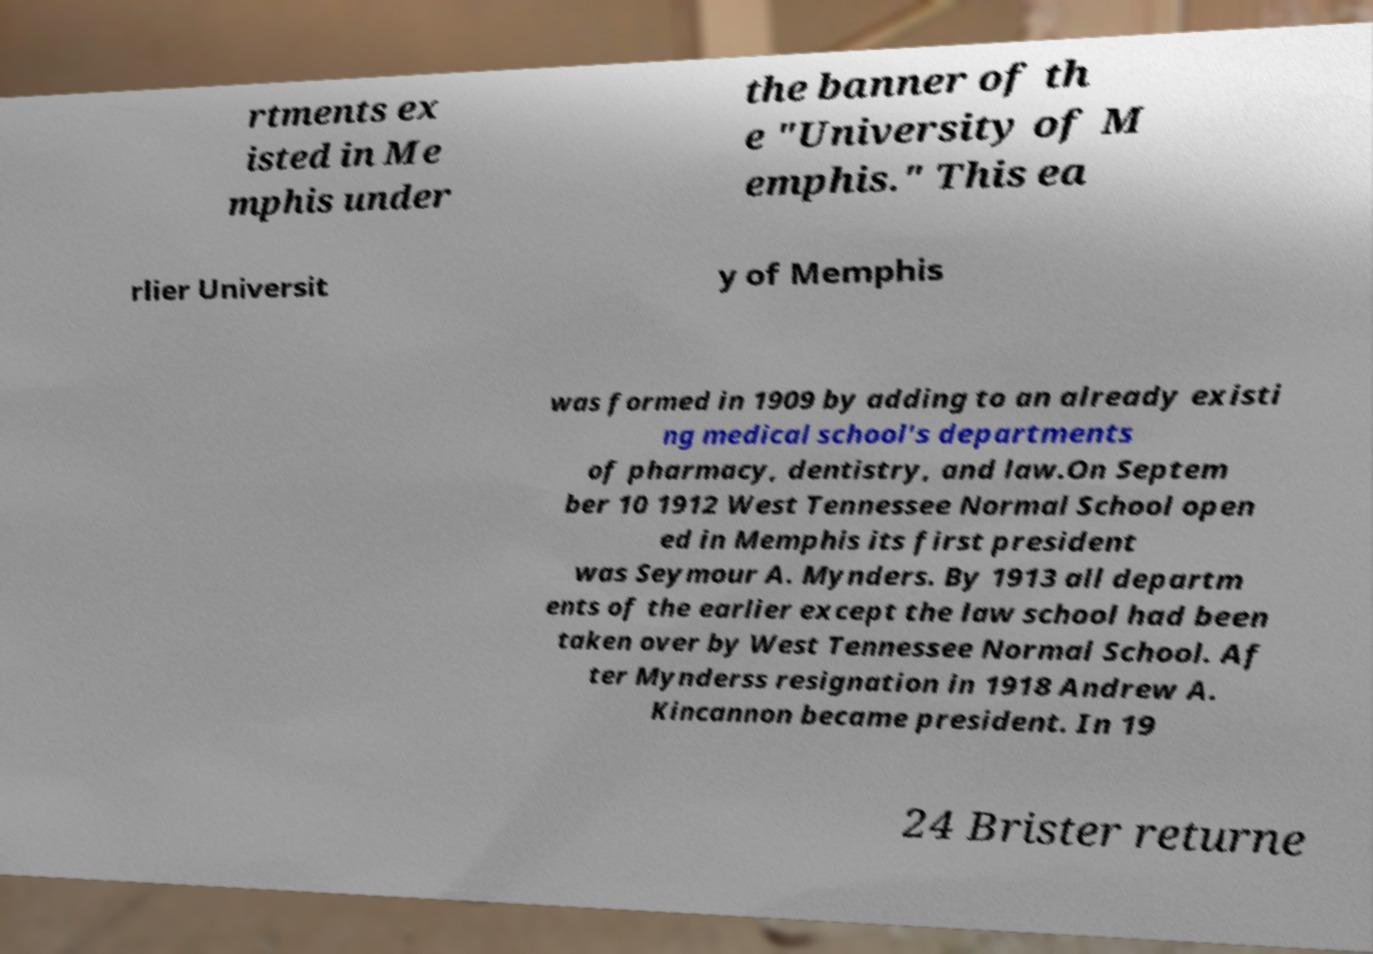Please identify and transcribe the text found in this image. rtments ex isted in Me mphis under the banner of th e "University of M emphis." This ea rlier Universit y of Memphis was formed in 1909 by adding to an already existi ng medical school's departments of pharmacy, dentistry, and law.On Septem ber 10 1912 West Tennessee Normal School open ed in Memphis its first president was Seymour A. Mynders. By 1913 all departm ents of the earlier except the law school had been taken over by West Tennessee Normal School. Af ter Mynderss resignation in 1918 Andrew A. Kincannon became president. In 19 24 Brister returne 